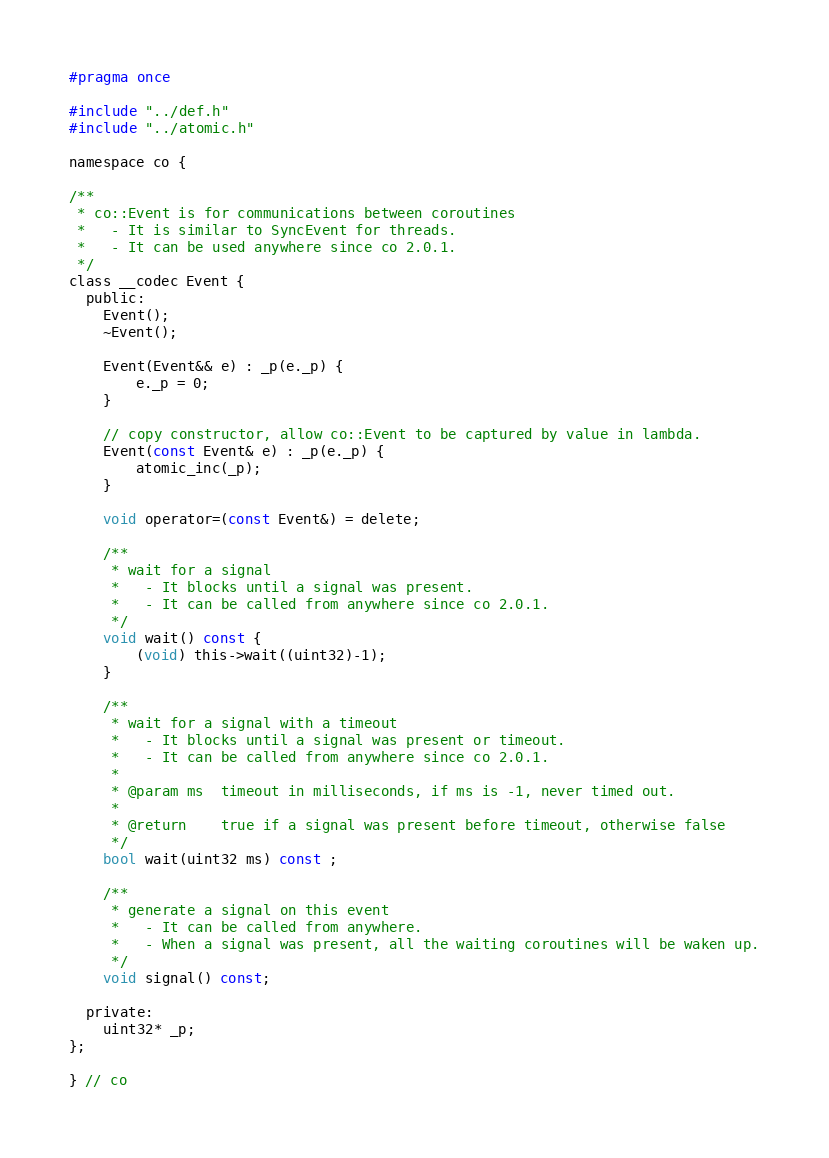Convert code to text. <code><loc_0><loc_0><loc_500><loc_500><_C_>#pragma once

#include "../def.h"
#include "../atomic.h"

namespace co {

/**
 * co::Event is for communications between coroutines
 *   - It is similar to SyncEvent for threads.
 *   - It can be used anywhere since co 2.0.1.
 */
class __codec Event {
  public:
    Event();
    ~Event();

    Event(Event&& e) : _p(e._p) {
        e._p = 0;
    }

    // copy constructor, allow co::Event to be captured by value in lambda.
    Event(const Event& e) : _p(e._p) {
        atomic_inc(_p);
    }

    void operator=(const Event&) = delete;

    /**
     * wait for a signal
     *   - It blocks until a signal was present.
     *   - It can be called from anywhere since co 2.0.1.
     */
    void wait() const {
        (void) this->wait((uint32)-1);
    }

    /**
     * wait for a signal with a timeout
     *   - It blocks until a signal was present or timeout.
     *   - It can be called from anywhere since co 2.0.1.
     *
     * @param ms  timeout in milliseconds, if ms is -1, never timed out.
     *
     * @return    true if a signal was present before timeout, otherwise false
     */
    bool wait(uint32 ms) const ;

    /**
     * generate a signal on this event
     *   - It can be called from anywhere.
     *   - When a signal was present, all the waiting coroutines will be waken up.
     */
    void signal() const;

  private:
    uint32* _p;
};

} // co
</code> 